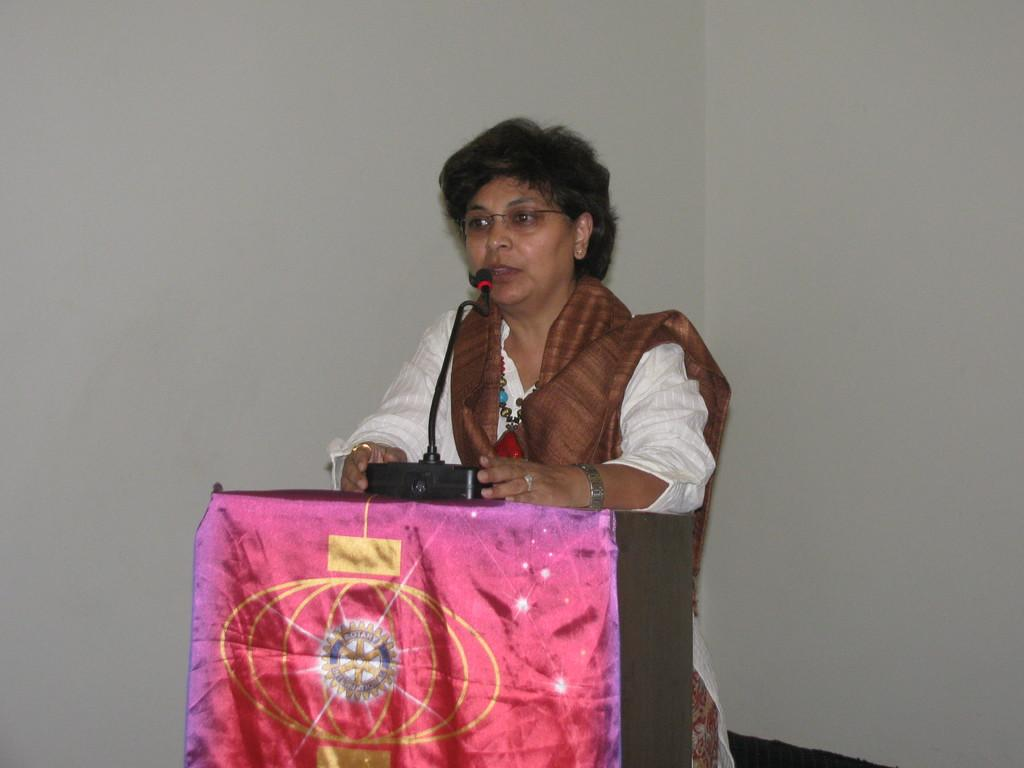What is the color of the wall in the image? The wall in the image is white. What object can be seen in the image related to sound? There is a mic in the image. Who is present in the image? There is a woman in the image. What accessory is the woman wearing on her face? The woman is wearing spectacles. What color is the dress worn by the woman in the image? The woman is wearing a white color dress. What disease is the woman in the image suffering from? There is no indication of any disease in the image, and therefore it cannot be determined. What is the woman in the image writing? There is no writing or any indication of writing in the image. 